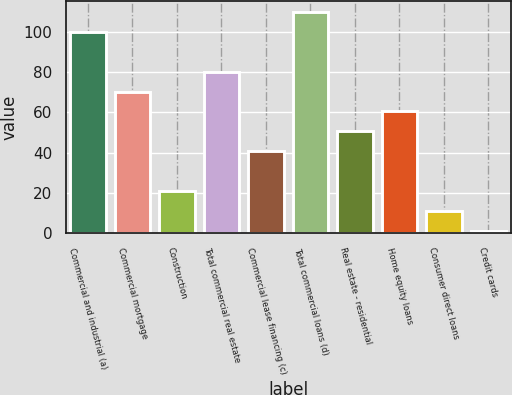Convert chart to OTSL. <chart><loc_0><loc_0><loc_500><loc_500><bar_chart><fcel>Commercial and industrial (a)<fcel>Commercial mortgage<fcel>Construction<fcel>Total commercial real estate<fcel>Commercial lease financing (c)<fcel>Total commercial loans (d)<fcel>Real estate - residential<fcel>Home equity loans<fcel>Consumer direct loans<fcel>Credit cards<nl><fcel>100<fcel>70.39<fcel>21.04<fcel>80.26<fcel>40.78<fcel>109.87<fcel>50.65<fcel>60.52<fcel>11.17<fcel>1.3<nl></chart> 